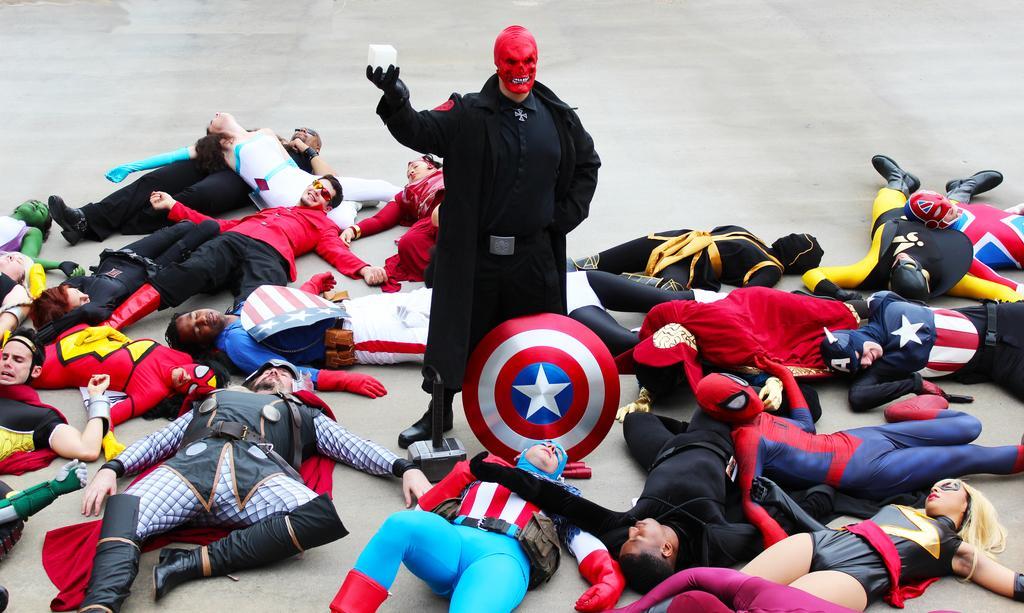Please provide a concise description of this image. In this image, there are group of people laying on the floor. Here is a person standing. These people wore fancy dresses. This looks like a captain america marvel shield. This man is holding an object in his hand. 